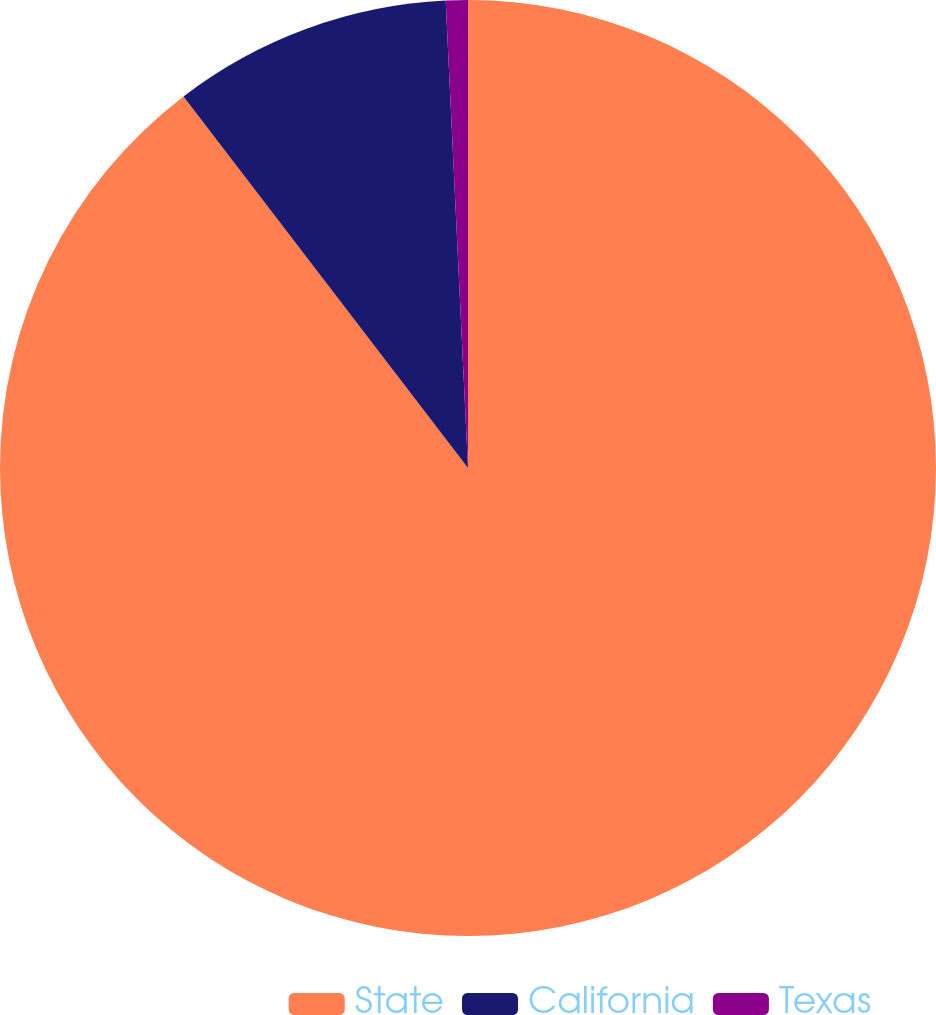Convert chart to OTSL. <chart><loc_0><loc_0><loc_500><loc_500><pie_chart><fcel>State<fcel>California<fcel>Texas<nl><fcel>89.6%<fcel>9.64%<fcel>0.76%<nl></chart> 